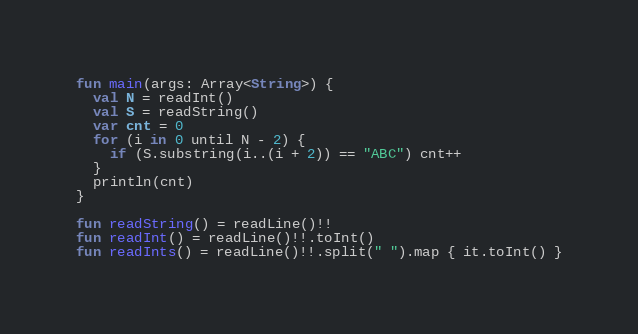<code> <loc_0><loc_0><loc_500><loc_500><_Kotlin_>fun main(args: Array<String>) {
  val N = readInt()
  val S = readString()
  var cnt = 0
  for (i in 0 until N - 2) {
    if (S.substring(i..(i + 2)) == "ABC") cnt++
  }
  println(cnt)
}

fun readString() = readLine()!!
fun readInt() = readLine()!!.toInt()
fun readInts() = readLine()!!.split(" ").map { it.toInt() }
</code> 